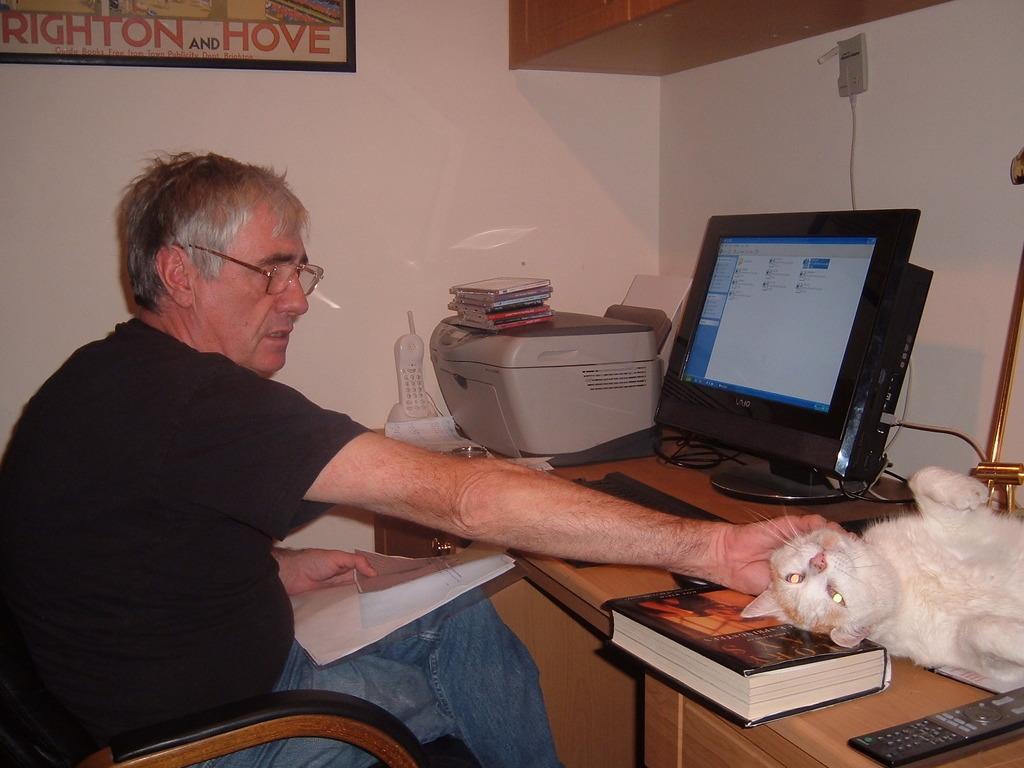Please provide a concise description of this image. The person is sitting in chair and holding a book in one of his hands and placed another hand on the cat and there is a table in front of him which has computer,printer,telephone,book and a cat on it. 